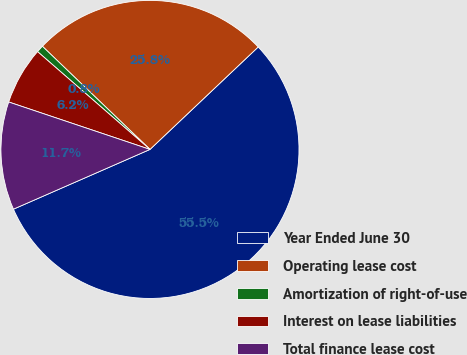Convert chart. <chart><loc_0><loc_0><loc_500><loc_500><pie_chart><fcel>Year Ended June 30<fcel>Operating lease cost<fcel>Amortization of right-of-use<fcel>Interest on lease liabilities<fcel>Total finance lease cost<nl><fcel>55.5%<fcel>25.77%<fcel>0.77%<fcel>6.24%<fcel>11.72%<nl></chart> 